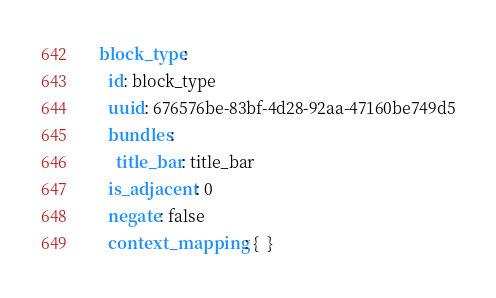<code> <loc_0><loc_0><loc_500><loc_500><_YAML_>  block_type:
    id: block_type
    uuid: 676576be-83bf-4d28-92aa-47160be749d5
    bundles:
      title_bar: title_bar
    is_adjacent: 0
    negate: false
    context_mapping: {  }
</code> 